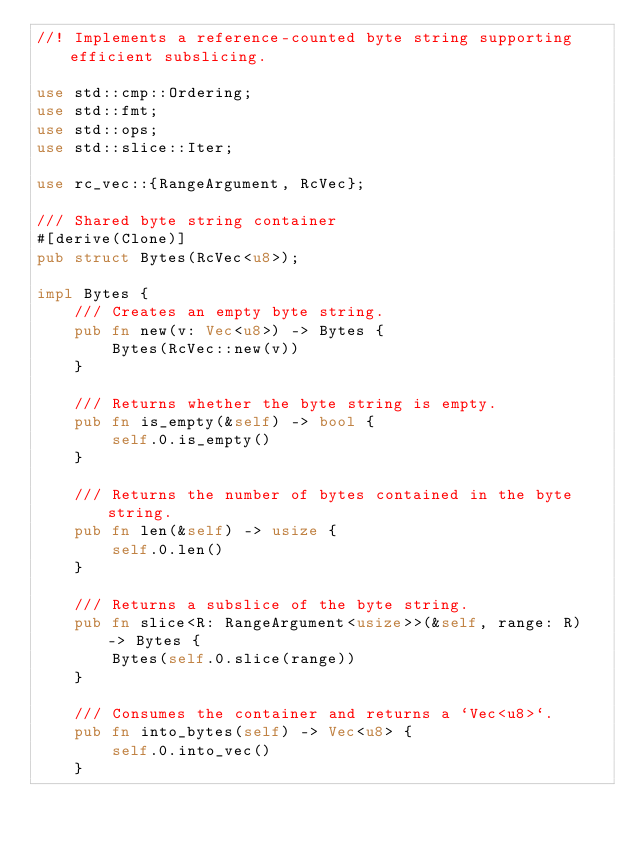Convert code to text. <code><loc_0><loc_0><loc_500><loc_500><_Rust_>//! Implements a reference-counted byte string supporting efficient subslicing.

use std::cmp::Ordering;
use std::fmt;
use std::ops;
use std::slice::Iter;

use rc_vec::{RangeArgument, RcVec};

/// Shared byte string container
#[derive(Clone)]
pub struct Bytes(RcVec<u8>);

impl Bytes {
    /// Creates an empty byte string.
    pub fn new(v: Vec<u8>) -> Bytes {
        Bytes(RcVec::new(v))
    }

    /// Returns whether the byte string is empty.
    pub fn is_empty(&self) -> bool {
        self.0.is_empty()
    }

    /// Returns the number of bytes contained in the byte string.
    pub fn len(&self) -> usize {
        self.0.len()
    }

    /// Returns a subslice of the byte string.
    pub fn slice<R: RangeArgument<usize>>(&self, range: R) -> Bytes {
        Bytes(self.0.slice(range))
    }

    /// Consumes the container and returns a `Vec<u8>`.
    pub fn into_bytes(self) -> Vec<u8> {
        self.0.into_vec()
    }
</code> 